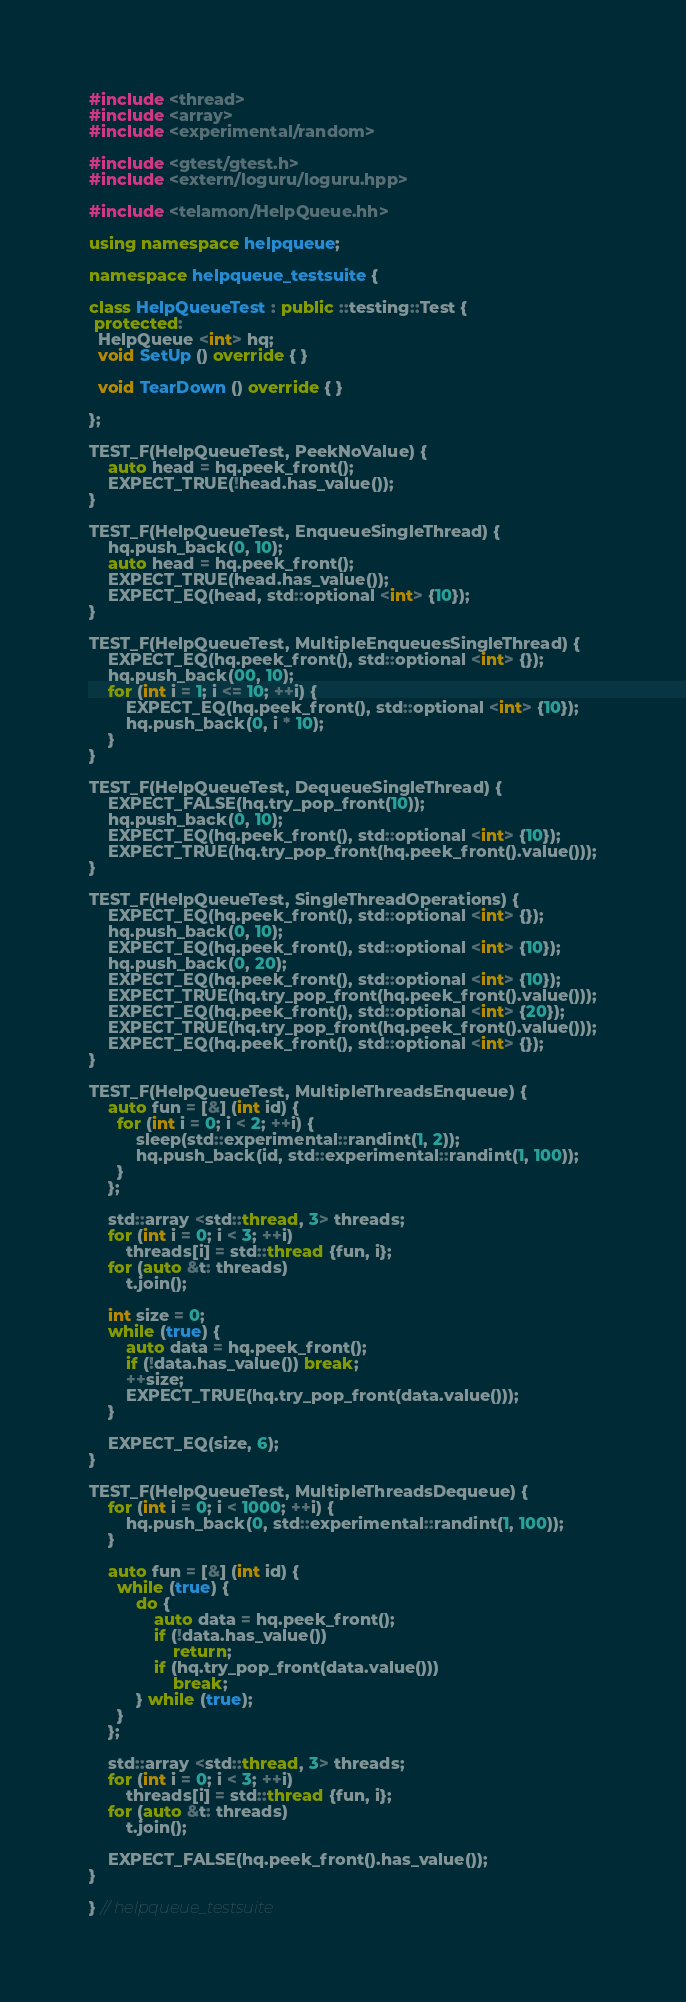<code> <loc_0><loc_0><loc_500><loc_500><_C++_>#include <thread>
#include <array>
#include <experimental/random>

#include <gtest/gtest.h>
#include <extern/loguru/loguru.hpp>

#include <telamon/HelpQueue.hh>

using namespace helpqueue;

namespace helpqueue_testsuite {

class HelpQueueTest : public ::testing::Test {
 protected:
  HelpQueue <int> hq;
  void SetUp () override { }

  void TearDown () override { }

};

TEST_F(HelpQueueTest, PeekNoValue) {
	auto head = hq.peek_front();
	EXPECT_TRUE(!head.has_value());
}

TEST_F(HelpQueueTest, EnqueueSingleThread) {
	hq.push_back(0, 10);
	auto head = hq.peek_front();
	EXPECT_TRUE(head.has_value());
	EXPECT_EQ(head, std::optional <int> {10});
}

TEST_F(HelpQueueTest, MultipleEnqueuesSingleThread) {
	EXPECT_EQ(hq.peek_front(), std::optional <int> {});
	hq.push_back(00, 10);
	for (int i = 1; i <= 10; ++i) {
		EXPECT_EQ(hq.peek_front(), std::optional <int> {10});
		hq.push_back(0, i * 10);
	}
}

TEST_F(HelpQueueTest, DequeueSingleThread) {
	EXPECT_FALSE(hq.try_pop_front(10));
	hq.push_back(0, 10);
	EXPECT_EQ(hq.peek_front(), std::optional <int> {10});
	EXPECT_TRUE(hq.try_pop_front(hq.peek_front().value()));
}

TEST_F(HelpQueueTest, SingleThreadOperations) {
	EXPECT_EQ(hq.peek_front(), std::optional <int> {});
	hq.push_back(0, 10);
	EXPECT_EQ(hq.peek_front(), std::optional <int> {10});
	hq.push_back(0, 20);
	EXPECT_EQ(hq.peek_front(), std::optional <int> {10});
	EXPECT_TRUE(hq.try_pop_front(hq.peek_front().value()));
	EXPECT_EQ(hq.peek_front(), std::optional <int> {20});
	EXPECT_TRUE(hq.try_pop_front(hq.peek_front().value()));
	EXPECT_EQ(hq.peek_front(), std::optional <int> {});
}

TEST_F(HelpQueueTest, MultipleThreadsEnqueue) {
	auto fun = [&] (int id) {
	  for (int i = 0; i < 2; ++i) {
		  sleep(std::experimental::randint(1, 2));
		  hq.push_back(id, std::experimental::randint(1, 100));
	  }
	};

	std::array <std::thread, 3> threads;
	for (int i = 0; i < 3; ++i)
		threads[i] = std::thread {fun, i};
	for (auto &t: threads)
		t.join();

	int size = 0;
	while (true) {
		auto data = hq.peek_front();
		if (!data.has_value()) break;
		++size;
		EXPECT_TRUE(hq.try_pop_front(data.value()));
	}

	EXPECT_EQ(size, 6);
}

TEST_F(HelpQueueTest, MultipleThreadsDequeue) {
	for (int i = 0; i < 1000; ++i) {
		hq.push_back(0, std::experimental::randint(1, 100));
	}

	auto fun = [&] (int id) {
	  while (true) {
		  do {
			  auto data = hq.peek_front();
			  if (!data.has_value())
				  return;
			  if (hq.try_pop_front(data.value()))
				  break;
		  } while (true);
	  }
	};

	std::array <std::thread, 3> threads;
	for (int i = 0; i < 3; ++i)
		threads[i] = std::thread {fun, i};
	for (auto &t: threads)
		t.join();

	EXPECT_FALSE(hq.peek_front().has_value());
}

} // helpqueue_testsuite
</code> 